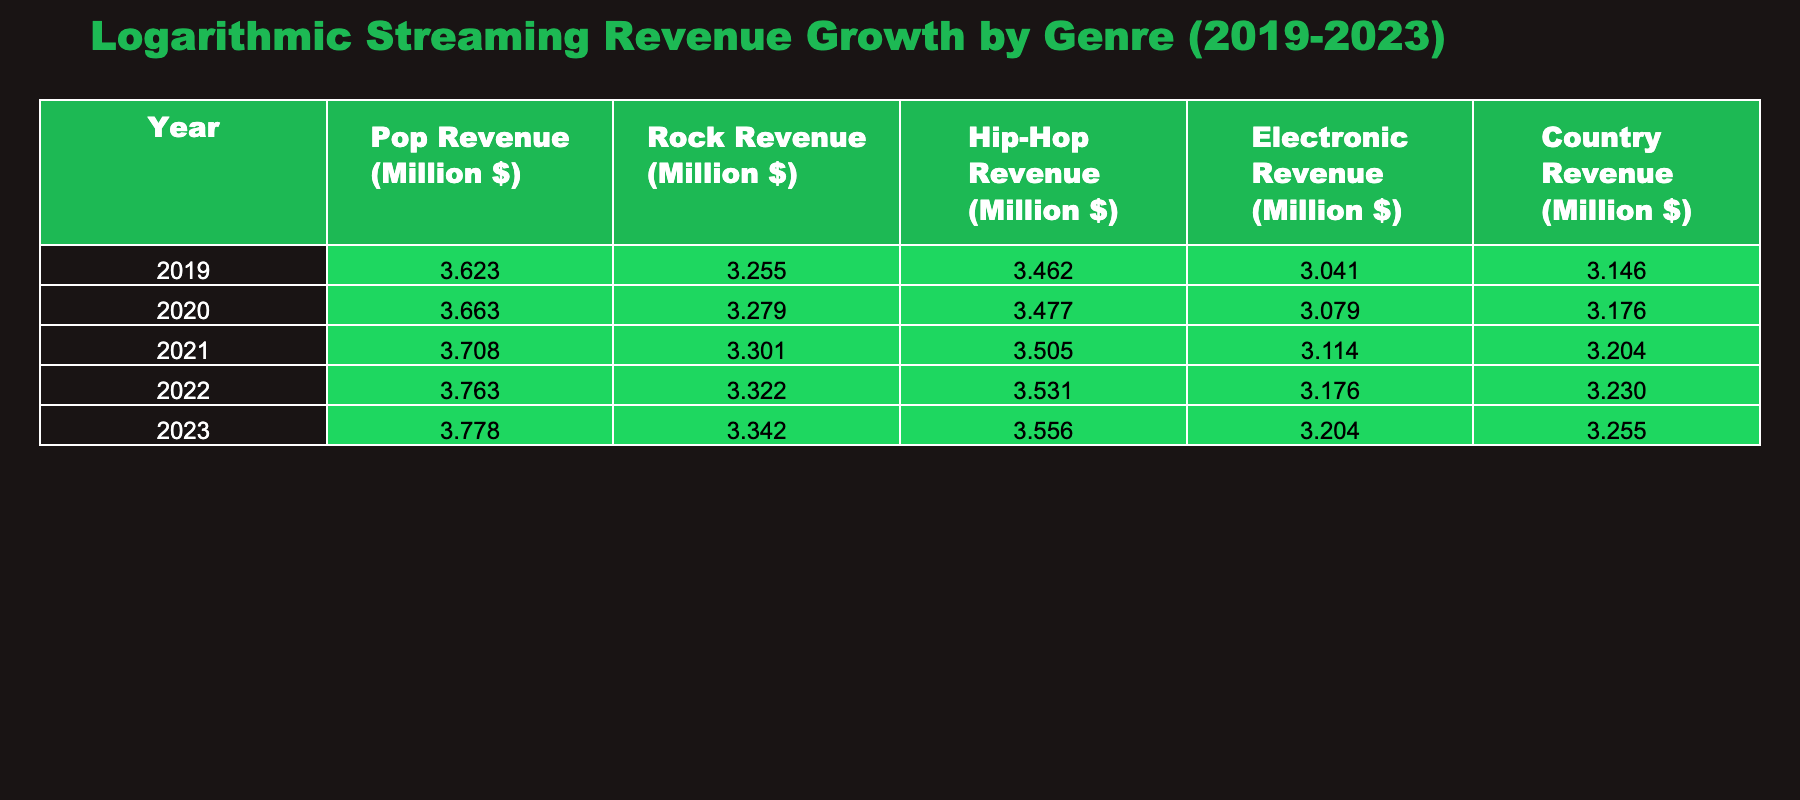What was the logarithmic revenue for Hip-Hop in 2023? In the table, we look for the value listed under the Hip-Hop Revenue column for the year 2023. Referring to the table, the value is approximately 3.556 (log10 of 3600 million dollars).
Answer: 3.556 What was the total logarithmic revenue for Pop from 2019 to 2023? To find the total, sum the logarithmic values for Pop from the years 2019 (3.623), 2020 (3.662), 2021 (3.707), 2022 (3.763), and 2023 (3.778). Adding these together gives a total value of approximately 18.533.
Answer: 18.533 Is the logarithmic revenue for Electronic music in 2022 greater than that for Country music in the same year? We compare the values for Electronic music and Country music in 2022. The logarithmic value for Electronic is approximately 3.176 (log10 of 1500 million) and for Country is approximately 3.230 (log10 of 1700 million). Since 3.176 is less than 3.230, the statement is false.
Answer: No What is the average logarithmic revenue for Rock across all years? To find the average, we first list the logarithmic revenue for Rock from 2019 to 2023: 3.255 (2019), 3.278 (2020), 3.301 (2021), 3.322 (2022), and 3.342 (2023). Summing these gives 16.498, and dividing by 5 (the number of years) results in an average of approximately 3.300.
Answer: 3.300 Was there a growth in logarithmic revenue for Country music from 2019 to 2023? We compare the logarithmic values for Country in 2019 (3.146) and 2023 (3.255). Since 3.255 is greater than 3.146, we conclude that there was indeed growth.
Answer: Yes What was the growth in logarithmic revenue for Hip-Hop from 2019 to 2023? We first identify the logarithmic values for Hip-Hop in 2019 (3.462) and in 2023 (3.556). We then calculate the growth by subtracting 3.462 from 3.556, resulting in a growth of approximately 0.094.
Answer: 0.094 How does the logarithmic revenue for Rock in 2022 compare to that of Pop in the same year? In 2022, the logarithmic revenue for Rock is approximately 3.322 and for Pop it is approximately 3.763. Since 3.763 is greater than 3.322, this indicates that recorded Pop's revenue exceeds that of Rock.
Answer: Pop's revenue is higher What is the percentage increase in logarithmic revenue for Electronic from 2019 to 2023? The logarithmic revenue for Electronic is 3.041 in 2019 and 3.206 in 2023. To calculate the percentage increase, take the difference (3.206 - 3.041), which equals 0.165. Then, divide by the original value (3.041): (0.165 / 3.041) * 100 gives approximately 5.42%.
Answer: 5.42% 